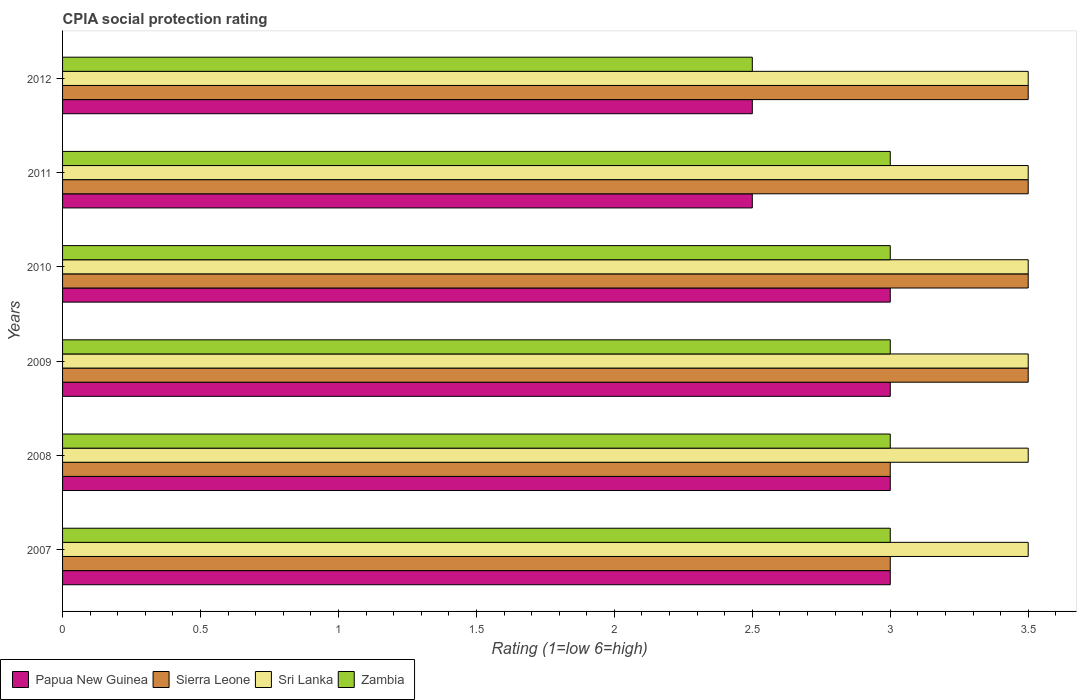Are the number of bars on each tick of the Y-axis equal?
Offer a terse response. Yes. What is the label of the 6th group of bars from the top?
Keep it short and to the point. 2007. What is the CPIA rating in Zambia in 2007?
Ensure brevity in your answer.  3. Across all years, what is the maximum CPIA rating in Sri Lanka?
Your answer should be very brief. 3.5. In which year was the CPIA rating in Sierra Leone maximum?
Offer a very short reply. 2009. What is the difference between the CPIA rating in Papua New Guinea in 2010 and the CPIA rating in Sierra Leone in 2012?
Give a very brief answer. -0.5. What is the average CPIA rating in Papua New Guinea per year?
Give a very brief answer. 2.83. What does the 1st bar from the top in 2011 represents?
Your answer should be very brief. Zambia. What does the 2nd bar from the bottom in 2007 represents?
Your answer should be very brief. Sierra Leone. Are all the bars in the graph horizontal?
Your response must be concise. Yes. Are the values on the major ticks of X-axis written in scientific E-notation?
Offer a terse response. No. What is the title of the graph?
Keep it short and to the point. CPIA social protection rating. What is the label or title of the Y-axis?
Provide a succinct answer. Years. What is the Rating (1=low 6=high) of Sierra Leone in 2007?
Give a very brief answer. 3. What is the Rating (1=low 6=high) of Zambia in 2007?
Make the answer very short. 3. What is the Rating (1=low 6=high) of Sri Lanka in 2008?
Your answer should be compact. 3.5. What is the Rating (1=low 6=high) of Zambia in 2008?
Make the answer very short. 3. What is the Rating (1=low 6=high) of Papua New Guinea in 2009?
Make the answer very short. 3. What is the Rating (1=low 6=high) of Sierra Leone in 2009?
Offer a very short reply. 3.5. What is the Rating (1=low 6=high) in Zambia in 2009?
Keep it short and to the point. 3. What is the Rating (1=low 6=high) of Papua New Guinea in 2010?
Give a very brief answer. 3. What is the Rating (1=low 6=high) in Sierra Leone in 2011?
Give a very brief answer. 3.5. What is the Rating (1=low 6=high) in Sri Lanka in 2011?
Ensure brevity in your answer.  3.5. What is the Rating (1=low 6=high) in Zambia in 2011?
Offer a terse response. 3. What is the Rating (1=low 6=high) of Sierra Leone in 2012?
Provide a succinct answer. 3.5. What is the Rating (1=low 6=high) in Zambia in 2012?
Keep it short and to the point. 2.5. Across all years, what is the maximum Rating (1=low 6=high) in Sierra Leone?
Keep it short and to the point. 3.5. Across all years, what is the maximum Rating (1=low 6=high) of Sri Lanka?
Make the answer very short. 3.5. Across all years, what is the maximum Rating (1=low 6=high) in Zambia?
Your answer should be compact. 3. Across all years, what is the minimum Rating (1=low 6=high) of Sri Lanka?
Offer a very short reply. 3.5. What is the total Rating (1=low 6=high) in Papua New Guinea in the graph?
Provide a succinct answer. 17. What is the total Rating (1=low 6=high) of Sri Lanka in the graph?
Keep it short and to the point. 21. What is the difference between the Rating (1=low 6=high) of Papua New Guinea in 2007 and that in 2008?
Offer a terse response. 0. What is the difference between the Rating (1=low 6=high) in Sierra Leone in 2007 and that in 2008?
Give a very brief answer. 0. What is the difference between the Rating (1=low 6=high) of Sierra Leone in 2007 and that in 2009?
Ensure brevity in your answer.  -0.5. What is the difference between the Rating (1=low 6=high) of Zambia in 2007 and that in 2010?
Your answer should be very brief. 0. What is the difference between the Rating (1=low 6=high) of Papua New Guinea in 2007 and that in 2011?
Offer a very short reply. 0.5. What is the difference between the Rating (1=low 6=high) in Sri Lanka in 2007 and that in 2011?
Keep it short and to the point. 0. What is the difference between the Rating (1=low 6=high) in Zambia in 2007 and that in 2011?
Offer a very short reply. 0. What is the difference between the Rating (1=low 6=high) of Zambia in 2007 and that in 2012?
Your response must be concise. 0.5. What is the difference between the Rating (1=low 6=high) of Papua New Guinea in 2008 and that in 2009?
Provide a short and direct response. 0. What is the difference between the Rating (1=low 6=high) of Zambia in 2008 and that in 2010?
Your answer should be compact. 0. What is the difference between the Rating (1=low 6=high) of Papua New Guinea in 2008 and that in 2011?
Keep it short and to the point. 0.5. What is the difference between the Rating (1=low 6=high) of Sri Lanka in 2008 and that in 2011?
Your answer should be very brief. 0. What is the difference between the Rating (1=low 6=high) of Zambia in 2008 and that in 2011?
Ensure brevity in your answer.  0. What is the difference between the Rating (1=low 6=high) in Papua New Guinea in 2008 and that in 2012?
Your response must be concise. 0.5. What is the difference between the Rating (1=low 6=high) of Sierra Leone in 2008 and that in 2012?
Your answer should be very brief. -0.5. What is the difference between the Rating (1=low 6=high) of Sri Lanka in 2008 and that in 2012?
Offer a terse response. 0. What is the difference between the Rating (1=low 6=high) in Zambia in 2008 and that in 2012?
Keep it short and to the point. 0.5. What is the difference between the Rating (1=low 6=high) of Papua New Guinea in 2009 and that in 2010?
Keep it short and to the point. 0. What is the difference between the Rating (1=low 6=high) of Sierra Leone in 2009 and that in 2010?
Keep it short and to the point. 0. What is the difference between the Rating (1=low 6=high) of Sierra Leone in 2009 and that in 2011?
Provide a short and direct response. 0. What is the difference between the Rating (1=low 6=high) of Sri Lanka in 2009 and that in 2011?
Offer a terse response. 0. What is the difference between the Rating (1=low 6=high) in Zambia in 2009 and that in 2011?
Provide a succinct answer. 0. What is the difference between the Rating (1=low 6=high) of Sierra Leone in 2009 and that in 2012?
Offer a terse response. 0. What is the difference between the Rating (1=low 6=high) of Sri Lanka in 2009 and that in 2012?
Provide a short and direct response. 0. What is the difference between the Rating (1=low 6=high) in Zambia in 2009 and that in 2012?
Keep it short and to the point. 0.5. What is the difference between the Rating (1=low 6=high) of Sri Lanka in 2010 and that in 2011?
Offer a terse response. 0. What is the difference between the Rating (1=low 6=high) in Zambia in 2010 and that in 2011?
Ensure brevity in your answer.  0. What is the difference between the Rating (1=low 6=high) of Papua New Guinea in 2010 and that in 2012?
Your answer should be very brief. 0.5. What is the difference between the Rating (1=low 6=high) of Sierra Leone in 2010 and that in 2012?
Give a very brief answer. 0. What is the difference between the Rating (1=low 6=high) of Zambia in 2010 and that in 2012?
Provide a short and direct response. 0.5. What is the difference between the Rating (1=low 6=high) of Papua New Guinea in 2007 and the Rating (1=low 6=high) of Sri Lanka in 2008?
Your answer should be very brief. -0.5. What is the difference between the Rating (1=low 6=high) in Papua New Guinea in 2007 and the Rating (1=low 6=high) in Zambia in 2008?
Keep it short and to the point. 0. What is the difference between the Rating (1=low 6=high) in Papua New Guinea in 2007 and the Rating (1=low 6=high) in Sri Lanka in 2009?
Ensure brevity in your answer.  -0.5. What is the difference between the Rating (1=low 6=high) in Sierra Leone in 2007 and the Rating (1=low 6=high) in Sri Lanka in 2009?
Make the answer very short. -0.5. What is the difference between the Rating (1=low 6=high) of Sri Lanka in 2007 and the Rating (1=low 6=high) of Zambia in 2009?
Your answer should be very brief. 0.5. What is the difference between the Rating (1=low 6=high) in Papua New Guinea in 2007 and the Rating (1=low 6=high) in Sierra Leone in 2010?
Your answer should be compact. -0.5. What is the difference between the Rating (1=low 6=high) in Papua New Guinea in 2007 and the Rating (1=low 6=high) in Sri Lanka in 2010?
Make the answer very short. -0.5. What is the difference between the Rating (1=low 6=high) of Sierra Leone in 2007 and the Rating (1=low 6=high) of Sri Lanka in 2010?
Your answer should be compact. -0.5. What is the difference between the Rating (1=low 6=high) in Sri Lanka in 2007 and the Rating (1=low 6=high) in Zambia in 2010?
Your response must be concise. 0.5. What is the difference between the Rating (1=low 6=high) of Papua New Guinea in 2007 and the Rating (1=low 6=high) of Sierra Leone in 2011?
Keep it short and to the point. -0.5. What is the difference between the Rating (1=low 6=high) of Papua New Guinea in 2007 and the Rating (1=low 6=high) of Sri Lanka in 2011?
Offer a terse response. -0.5. What is the difference between the Rating (1=low 6=high) in Papua New Guinea in 2007 and the Rating (1=low 6=high) in Zambia in 2011?
Offer a terse response. 0. What is the difference between the Rating (1=low 6=high) in Sierra Leone in 2007 and the Rating (1=low 6=high) in Sri Lanka in 2011?
Make the answer very short. -0.5. What is the difference between the Rating (1=low 6=high) in Sri Lanka in 2007 and the Rating (1=low 6=high) in Zambia in 2011?
Provide a short and direct response. 0.5. What is the difference between the Rating (1=low 6=high) of Papua New Guinea in 2007 and the Rating (1=low 6=high) of Sierra Leone in 2012?
Give a very brief answer. -0.5. What is the difference between the Rating (1=low 6=high) of Papua New Guinea in 2007 and the Rating (1=low 6=high) of Zambia in 2012?
Offer a very short reply. 0.5. What is the difference between the Rating (1=low 6=high) in Sierra Leone in 2007 and the Rating (1=low 6=high) in Sri Lanka in 2012?
Keep it short and to the point. -0.5. What is the difference between the Rating (1=low 6=high) of Sri Lanka in 2007 and the Rating (1=low 6=high) of Zambia in 2012?
Give a very brief answer. 1. What is the difference between the Rating (1=low 6=high) in Papua New Guinea in 2008 and the Rating (1=low 6=high) in Sierra Leone in 2009?
Keep it short and to the point. -0.5. What is the difference between the Rating (1=low 6=high) in Papua New Guinea in 2008 and the Rating (1=low 6=high) in Sri Lanka in 2009?
Provide a short and direct response. -0.5. What is the difference between the Rating (1=low 6=high) in Papua New Guinea in 2008 and the Rating (1=low 6=high) in Zambia in 2009?
Your response must be concise. 0. What is the difference between the Rating (1=low 6=high) of Sierra Leone in 2008 and the Rating (1=low 6=high) of Zambia in 2009?
Your answer should be compact. 0. What is the difference between the Rating (1=low 6=high) of Sri Lanka in 2008 and the Rating (1=low 6=high) of Zambia in 2009?
Your response must be concise. 0.5. What is the difference between the Rating (1=low 6=high) of Papua New Guinea in 2008 and the Rating (1=low 6=high) of Sri Lanka in 2010?
Your response must be concise. -0.5. What is the difference between the Rating (1=low 6=high) of Papua New Guinea in 2008 and the Rating (1=low 6=high) of Zambia in 2010?
Provide a succinct answer. 0. What is the difference between the Rating (1=low 6=high) of Sierra Leone in 2008 and the Rating (1=low 6=high) of Sri Lanka in 2010?
Your answer should be very brief. -0.5. What is the difference between the Rating (1=low 6=high) in Papua New Guinea in 2008 and the Rating (1=low 6=high) in Zambia in 2011?
Offer a terse response. 0. What is the difference between the Rating (1=low 6=high) in Sierra Leone in 2008 and the Rating (1=low 6=high) in Sri Lanka in 2011?
Offer a terse response. -0.5. What is the difference between the Rating (1=low 6=high) of Papua New Guinea in 2008 and the Rating (1=low 6=high) of Zambia in 2012?
Your answer should be very brief. 0.5. What is the difference between the Rating (1=low 6=high) of Sierra Leone in 2008 and the Rating (1=low 6=high) of Sri Lanka in 2012?
Give a very brief answer. -0.5. What is the difference between the Rating (1=low 6=high) in Sierra Leone in 2008 and the Rating (1=low 6=high) in Zambia in 2012?
Provide a short and direct response. 0.5. What is the difference between the Rating (1=low 6=high) in Papua New Guinea in 2009 and the Rating (1=low 6=high) in Sierra Leone in 2010?
Offer a very short reply. -0.5. What is the difference between the Rating (1=low 6=high) in Sierra Leone in 2009 and the Rating (1=low 6=high) in Sri Lanka in 2010?
Your answer should be compact. 0. What is the difference between the Rating (1=low 6=high) in Papua New Guinea in 2009 and the Rating (1=low 6=high) in Sierra Leone in 2011?
Give a very brief answer. -0.5. What is the difference between the Rating (1=low 6=high) of Papua New Guinea in 2009 and the Rating (1=low 6=high) of Zambia in 2011?
Offer a very short reply. 0. What is the difference between the Rating (1=low 6=high) in Sri Lanka in 2009 and the Rating (1=low 6=high) in Zambia in 2011?
Your response must be concise. 0.5. What is the difference between the Rating (1=low 6=high) of Papua New Guinea in 2009 and the Rating (1=low 6=high) of Sierra Leone in 2012?
Keep it short and to the point. -0.5. What is the difference between the Rating (1=low 6=high) in Papua New Guinea in 2009 and the Rating (1=low 6=high) in Zambia in 2012?
Provide a succinct answer. 0.5. What is the difference between the Rating (1=low 6=high) of Sierra Leone in 2009 and the Rating (1=low 6=high) of Sri Lanka in 2012?
Provide a short and direct response. 0. What is the difference between the Rating (1=low 6=high) of Sierra Leone in 2009 and the Rating (1=low 6=high) of Zambia in 2012?
Your response must be concise. 1. What is the difference between the Rating (1=low 6=high) in Papua New Guinea in 2010 and the Rating (1=low 6=high) in Sri Lanka in 2011?
Your answer should be very brief. -0.5. What is the difference between the Rating (1=low 6=high) in Sierra Leone in 2010 and the Rating (1=low 6=high) in Zambia in 2011?
Your answer should be compact. 0.5. What is the difference between the Rating (1=low 6=high) of Sierra Leone in 2010 and the Rating (1=low 6=high) of Zambia in 2012?
Provide a short and direct response. 1. What is the difference between the Rating (1=low 6=high) in Sri Lanka in 2010 and the Rating (1=low 6=high) in Zambia in 2012?
Make the answer very short. 1. What is the difference between the Rating (1=low 6=high) in Sierra Leone in 2011 and the Rating (1=low 6=high) in Sri Lanka in 2012?
Keep it short and to the point. 0. What is the difference between the Rating (1=low 6=high) of Sri Lanka in 2011 and the Rating (1=low 6=high) of Zambia in 2012?
Your response must be concise. 1. What is the average Rating (1=low 6=high) of Papua New Guinea per year?
Make the answer very short. 2.83. What is the average Rating (1=low 6=high) of Sierra Leone per year?
Your answer should be compact. 3.33. What is the average Rating (1=low 6=high) in Sri Lanka per year?
Give a very brief answer. 3.5. What is the average Rating (1=low 6=high) in Zambia per year?
Ensure brevity in your answer.  2.92. In the year 2007, what is the difference between the Rating (1=low 6=high) of Papua New Guinea and Rating (1=low 6=high) of Sri Lanka?
Keep it short and to the point. -0.5. In the year 2007, what is the difference between the Rating (1=low 6=high) in Papua New Guinea and Rating (1=low 6=high) in Zambia?
Make the answer very short. 0. In the year 2007, what is the difference between the Rating (1=low 6=high) of Sierra Leone and Rating (1=low 6=high) of Sri Lanka?
Your response must be concise. -0.5. In the year 2008, what is the difference between the Rating (1=low 6=high) in Papua New Guinea and Rating (1=low 6=high) in Zambia?
Offer a terse response. 0. In the year 2008, what is the difference between the Rating (1=low 6=high) of Sierra Leone and Rating (1=low 6=high) of Zambia?
Offer a terse response. 0. In the year 2008, what is the difference between the Rating (1=low 6=high) of Sri Lanka and Rating (1=low 6=high) of Zambia?
Ensure brevity in your answer.  0.5. In the year 2009, what is the difference between the Rating (1=low 6=high) of Papua New Guinea and Rating (1=low 6=high) of Sri Lanka?
Provide a short and direct response. -0.5. In the year 2009, what is the difference between the Rating (1=low 6=high) of Papua New Guinea and Rating (1=low 6=high) of Zambia?
Your answer should be compact. 0. In the year 2009, what is the difference between the Rating (1=low 6=high) of Sierra Leone and Rating (1=low 6=high) of Sri Lanka?
Your response must be concise. 0. In the year 2009, what is the difference between the Rating (1=low 6=high) of Sierra Leone and Rating (1=low 6=high) of Zambia?
Give a very brief answer. 0.5. In the year 2010, what is the difference between the Rating (1=low 6=high) of Papua New Guinea and Rating (1=low 6=high) of Sierra Leone?
Give a very brief answer. -0.5. In the year 2010, what is the difference between the Rating (1=low 6=high) of Papua New Guinea and Rating (1=low 6=high) of Zambia?
Make the answer very short. 0. In the year 2010, what is the difference between the Rating (1=low 6=high) in Sierra Leone and Rating (1=low 6=high) in Sri Lanka?
Make the answer very short. 0. In the year 2010, what is the difference between the Rating (1=low 6=high) in Sierra Leone and Rating (1=low 6=high) in Zambia?
Your answer should be compact. 0.5. In the year 2011, what is the difference between the Rating (1=low 6=high) of Papua New Guinea and Rating (1=low 6=high) of Sri Lanka?
Ensure brevity in your answer.  -1. In the year 2011, what is the difference between the Rating (1=low 6=high) of Sierra Leone and Rating (1=low 6=high) of Zambia?
Keep it short and to the point. 0.5. In the year 2011, what is the difference between the Rating (1=low 6=high) of Sri Lanka and Rating (1=low 6=high) of Zambia?
Make the answer very short. 0.5. In the year 2012, what is the difference between the Rating (1=low 6=high) of Papua New Guinea and Rating (1=low 6=high) of Sierra Leone?
Keep it short and to the point. -1. In the year 2012, what is the difference between the Rating (1=low 6=high) in Papua New Guinea and Rating (1=low 6=high) in Zambia?
Make the answer very short. 0. In the year 2012, what is the difference between the Rating (1=low 6=high) of Sierra Leone and Rating (1=low 6=high) of Zambia?
Offer a very short reply. 1. In the year 2012, what is the difference between the Rating (1=low 6=high) in Sri Lanka and Rating (1=low 6=high) in Zambia?
Make the answer very short. 1. What is the ratio of the Rating (1=low 6=high) in Papua New Guinea in 2007 to that in 2008?
Your answer should be very brief. 1. What is the ratio of the Rating (1=low 6=high) of Sri Lanka in 2007 to that in 2008?
Provide a short and direct response. 1. What is the ratio of the Rating (1=low 6=high) in Papua New Guinea in 2007 to that in 2009?
Ensure brevity in your answer.  1. What is the ratio of the Rating (1=low 6=high) in Sri Lanka in 2007 to that in 2009?
Offer a terse response. 1. What is the ratio of the Rating (1=low 6=high) of Sierra Leone in 2007 to that in 2010?
Provide a short and direct response. 0.86. What is the ratio of the Rating (1=low 6=high) in Papua New Guinea in 2007 to that in 2011?
Make the answer very short. 1.2. What is the ratio of the Rating (1=low 6=high) of Sri Lanka in 2007 to that in 2011?
Make the answer very short. 1. What is the ratio of the Rating (1=low 6=high) in Zambia in 2007 to that in 2011?
Offer a terse response. 1. What is the ratio of the Rating (1=low 6=high) in Papua New Guinea in 2007 to that in 2012?
Your answer should be compact. 1.2. What is the ratio of the Rating (1=low 6=high) in Zambia in 2007 to that in 2012?
Your answer should be compact. 1.2. What is the ratio of the Rating (1=low 6=high) of Papua New Guinea in 2008 to that in 2009?
Your answer should be very brief. 1. What is the ratio of the Rating (1=low 6=high) in Sierra Leone in 2008 to that in 2009?
Your answer should be compact. 0.86. What is the ratio of the Rating (1=low 6=high) in Sri Lanka in 2008 to that in 2009?
Keep it short and to the point. 1. What is the ratio of the Rating (1=low 6=high) of Papua New Guinea in 2008 to that in 2010?
Offer a very short reply. 1. What is the ratio of the Rating (1=low 6=high) of Zambia in 2008 to that in 2010?
Make the answer very short. 1. What is the ratio of the Rating (1=low 6=high) of Papua New Guinea in 2008 to that in 2011?
Keep it short and to the point. 1.2. What is the ratio of the Rating (1=low 6=high) of Sri Lanka in 2008 to that in 2011?
Offer a very short reply. 1. What is the ratio of the Rating (1=low 6=high) in Papua New Guinea in 2008 to that in 2012?
Make the answer very short. 1.2. What is the ratio of the Rating (1=low 6=high) of Sri Lanka in 2008 to that in 2012?
Your response must be concise. 1. What is the ratio of the Rating (1=low 6=high) in Zambia in 2009 to that in 2010?
Your answer should be compact. 1. What is the ratio of the Rating (1=low 6=high) in Papua New Guinea in 2009 to that in 2011?
Offer a very short reply. 1.2. What is the ratio of the Rating (1=low 6=high) of Sri Lanka in 2009 to that in 2012?
Your answer should be very brief. 1. What is the ratio of the Rating (1=low 6=high) in Sri Lanka in 2010 to that in 2012?
Keep it short and to the point. 1. What is the ratio of the Rating (1=low 6=high) of Sierra Leone in 2011 to that in 2012?
Offer a very short reply. 1. What is the difference between the highest and the second highest Rating (1=low 6=high) of Papua New Guinea?
Provide a succinct answer. 0. What is the difference between the highest and the second highest Rating (1=low 6=high) in Zambia?
Your answer should be compact. 0. 